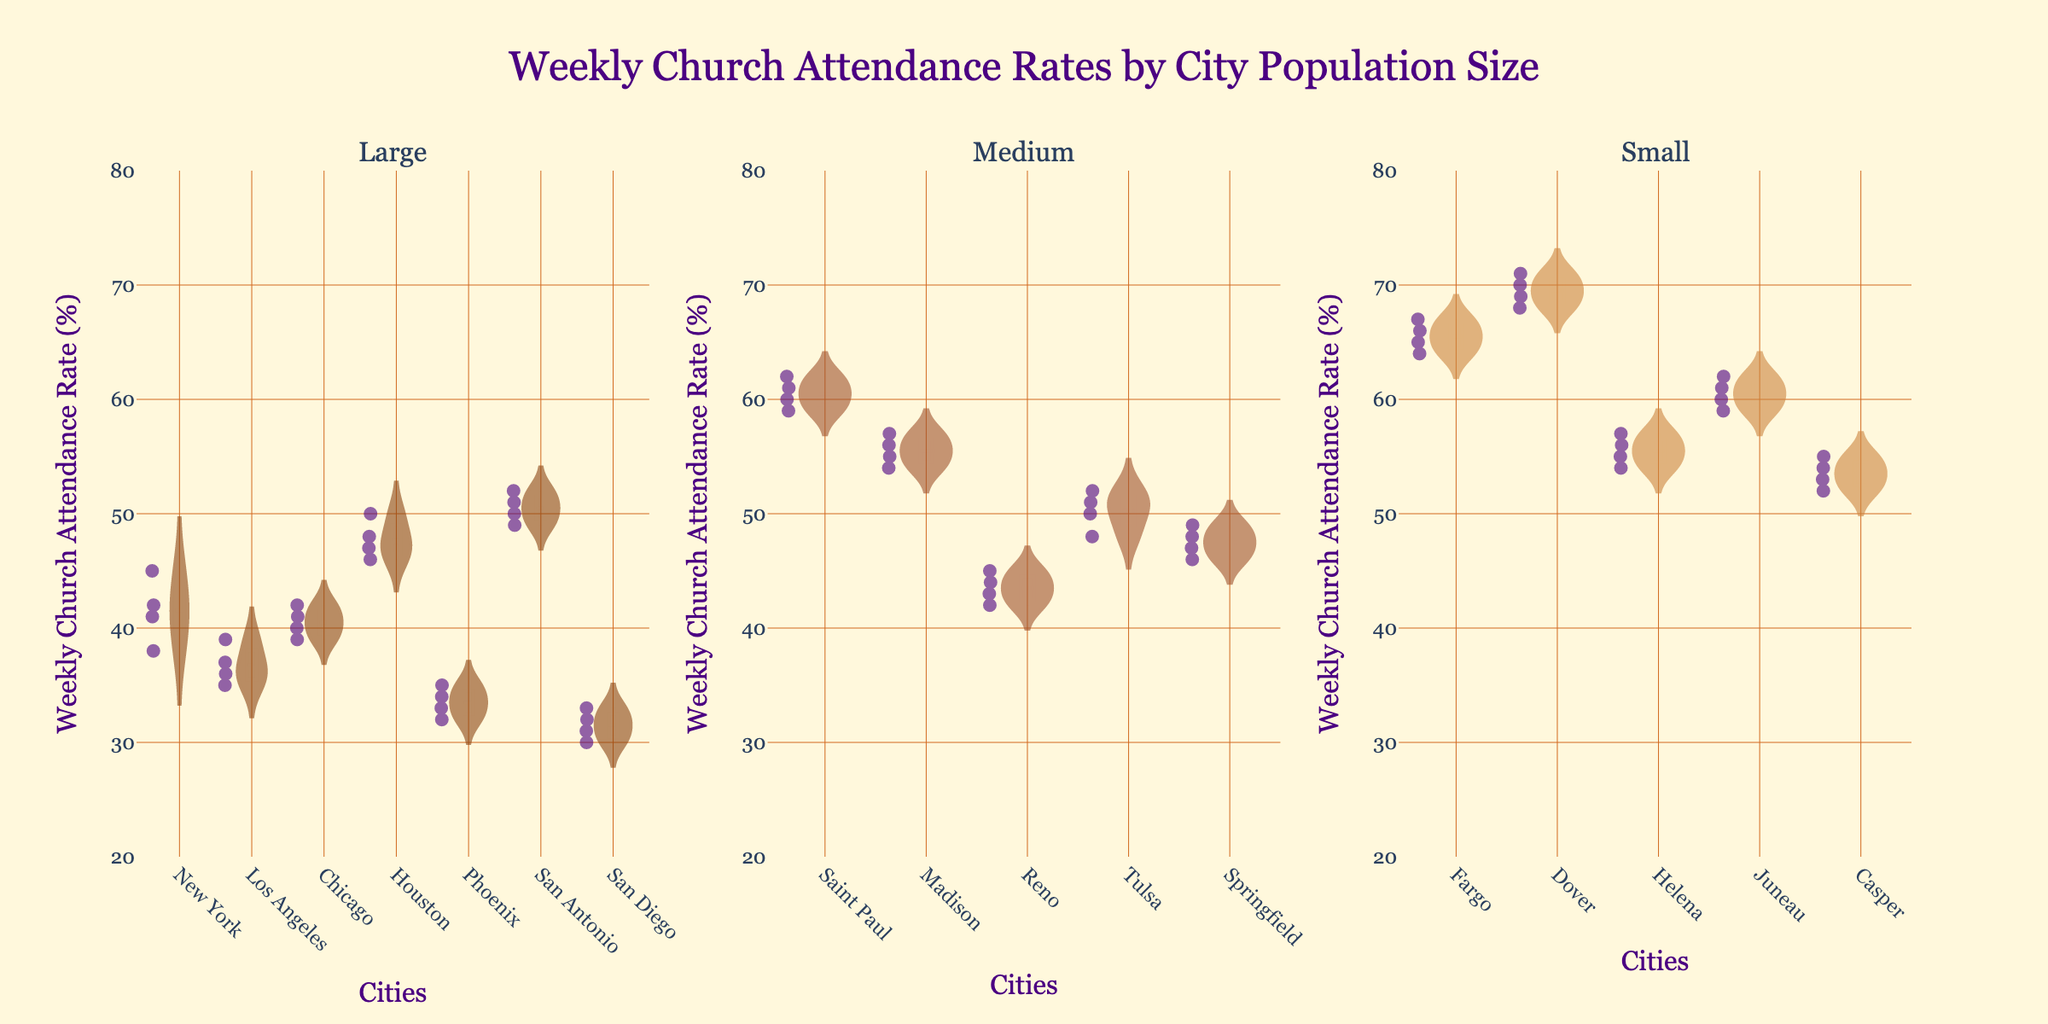What is the title of the figure? The title of the figure can be found at the top and reads "Weekly Church Attendance Rates by City Population Size".
Answer: Weekly Church Attendance Rates by City Population Size What are the three population sizes displayed in the subplots? The subplots are titled based on the population sizes of the cities: "Large", "Medium", and "Small".
Answer: Large, Medium, Small Which city in the "Large" population size has the highest average weekly church attendance rate? One needs to observe the violin plots under the "Large" population size and look at the distribution and central tendency (mean line) of each city. Houston has the highest average attendance rate.
Answer: Houston In the "Medium" population size, which city shows the widest range of weekly church attendance rates? The range of weekly church attendance rates is shown by the spread of the violin plot for each city in the "Medium" population size subplot. Saint Paul has the widest range.
Answer: Saint Paul Compare the median weekly church attendance rate of large and small population cities. Which has the higher median rate? The median is represented by the central tendency line (mean line) within each violin plot. Observing the subplots, the median of the small population size cities is higher than that of the large population size cities.
Answer: Small How does the church attendance rate variance in "Phoenix" compare to "San Antonio"? To compare variances, observe the spread and shape of the violin plots. Phoenix has a narrower spread compared to San Antonio, indicating less variance.
Answer: Phoenix has less variance What is the lowest weekly church attendance rate observed across all large cities? By examining the lowest points of the violin plots within the "Large" population size subplot, the lowest rate observed is 30% (San Diego).
Answer: 30% What is the color used for the fill of the medium population size violin plots? The fill color used for the medium population size violin plots is an earth tone, a shade of brown (SaddleBrown).
Answer: SaddleBrown Which city in the "Small" population size has the highest peak for church attendance? One must look at the top of the violin plots in the "Small" population size to find the highest peak. Dover has the highest peak attendance rate.
Answer: Dover What is the range of the y-axis in the figure? The y-axis range is displayed alongside the violin plots, showing from 20% to 80%.
Answer: 20-80% 